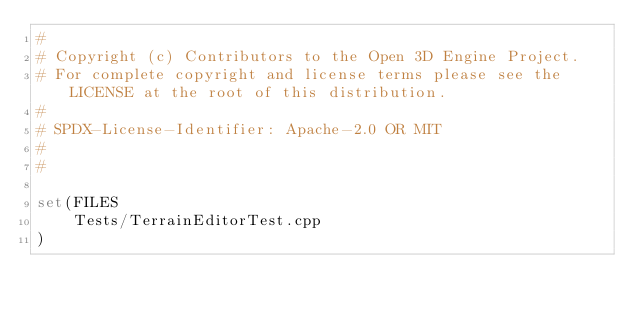Convert code to text. <code><loc_0><loc_0><loc_500><loc_500><_CMake_>#
# Copyright (c) Contributors to the Open 3D Engine Project.
# For complete copyright and license terms please see the LICENSE at the root of this distribution.
#
# SPDX-License-Identifier: Apache-2.0 OR MIT
#
#

set(FILES
    Tests/TerrainEditorTest.cpp
)
</code> 